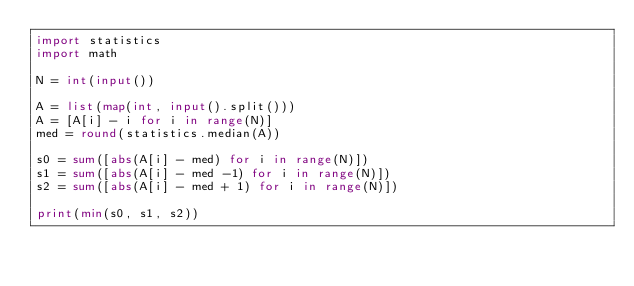Convert code to text. <code><loc_0><loc_0><loc_500><loc_500><_Python_>import statistics
import math

N = int(input())

A = list(map(int, input().split()))
A = [A[i] - i for i in range(N)]
med = round(statistics.median(A))

s0 = sum([abs(A[i] - med) for i in range(N)])
s1 = sum([abs(A[i] - med -1) for i in range(N)])
s2 = sum([abs(A[i] - med + 1) for i in range(N)])

print(min(s0, s1, s2))</code> 